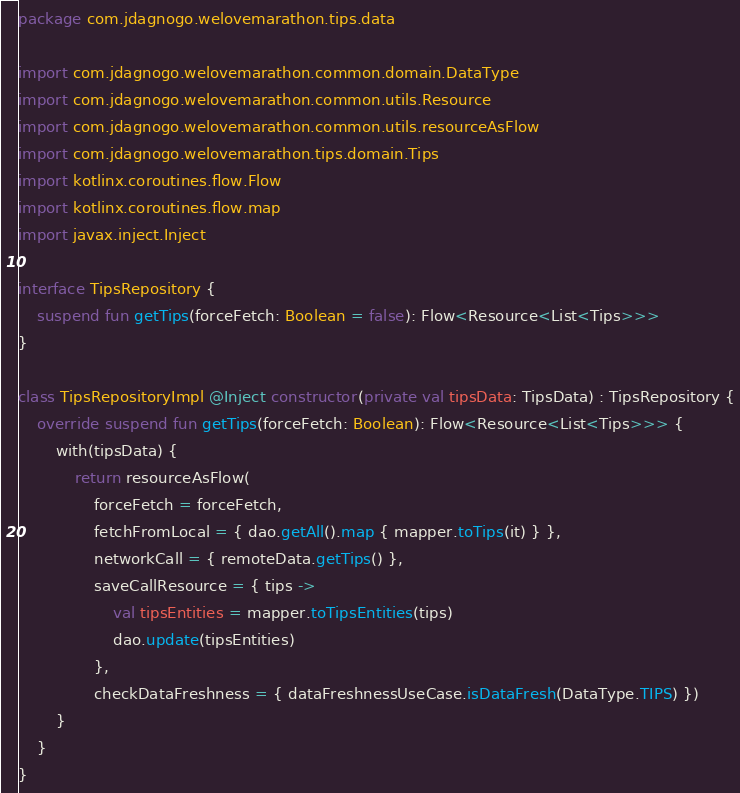Convert code to text. <code><loc_0><loc_0><loc_500><loc_500><_Kotlin_>package com.jdagnogo.welovemarathon.tips.data

import com.jdagnogo.welovemarathon.common.domain.DataType
import com.jdagnogo.welovemarathon.common.utils.Resource
import com.jdagnogo.welovemarathon.common.utils.resourceAsFlow
import com.jdagnogo.welovemarathon.tips.domain.Tips
import kotlinx.coroutines.flow.Flow
import kotlinx.coroutines.flow.map
import javax.inject.Inject

interface TipsRepository {
    suspend fun getTips(forceFetch: Boolean = false): Flow<Resource<List<Tips>>>
}

class TipsRepositoryImpl @Inject constructor(private val tipsData: TipsData) : TipsRepository {
    override suspend fun getTips(forceFetch: Boolean): Flow<Resource<List<Tips>>> {
        with(tipsData) {
            return resourceAsFlow(
                forceFetch = forceFetch,
                fetchFromLocal = { dao.getAll().map { mapper.toTips(it) } },
                networkCall = { remoteData.getTips() },
                saveCallResource = { tips ->
                    val tipsEntities = mapper.toTipsEntities(tips)
                    dao.update(tipsEntities)
                },
                checkDataFreshness = { dataFreshnessUseCase.isDataFresh(DataType.TIPS) })
        }
    }
}
</code> 